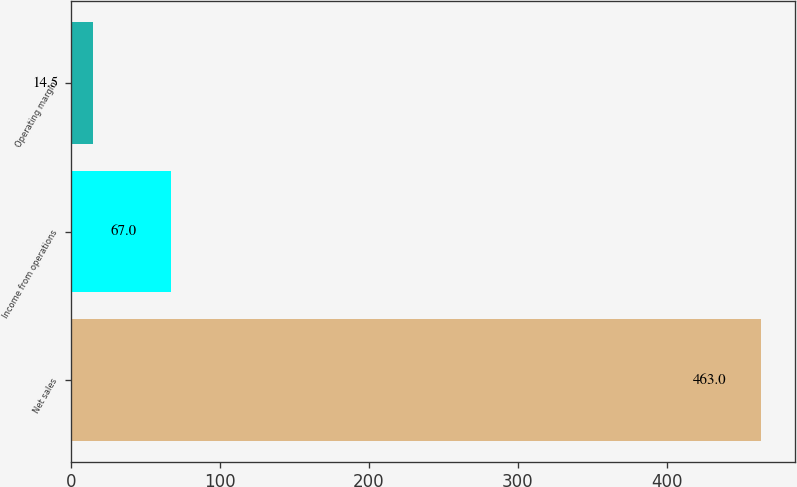Convert chart. <chart><loc_0><loc_0><loc_500><loc_500><bar_chart><fcel>Net sales<fcel>Income from operations<fcel>Operating margin<nl><fcel>463<fcel>67<fcel>14.5<nl></chart> 